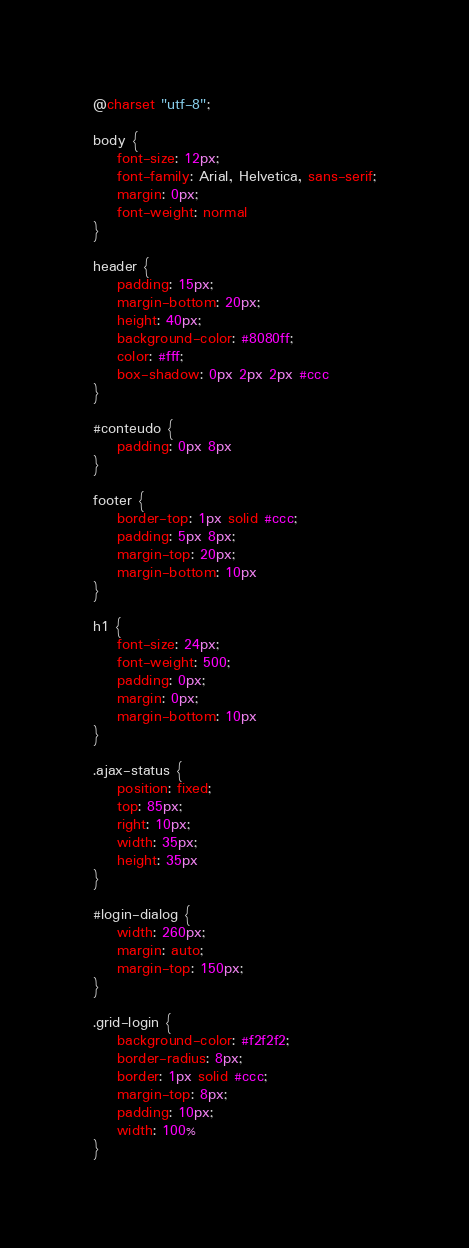Convert code to text. <code><loc_0><loc_0><loc_500><loc_500><_CSS_>@charset "utf-8";

body {
	font-size: 12px;
	font-family: Arial, Helvetica, sans-serif;
	margin: 0px;
	font-weight: normal
}

header {
	padding: 15px;
	margin-bottom: 20px;
	height: 40px;
	background-color: #8080ff;
	color: #fff;
	box-shadow: 0px 2px 2px #ccc
}

#conteudo {
	padding: 0px 8px
}

footer {
	border-top: 1px solid #ccc;
	padding: 5px 8px;
	margin-top: 20px;
	margin-bottom: 10px
}

h1 {
	font-size: 24px;
	font-weight: 500;
	padding: 0px;
	margin: 0px;
	margin-bottom: 10px
}

.ajax-status {
	position: fixed;
	top: 85px;
	right: 10px;
	width: 35px;
	height: 35px
}

#login-dialog {
	width: 260px;
	margin: auto;
	margin-top: 150px;
}

.grid-login {
	background-color: #f2f2f2;
	border-radius: 8px;
	border: 1px solid #ccc;
	margin-top: 8px;
	padding: 10px;
	width: 100%
}</code> 